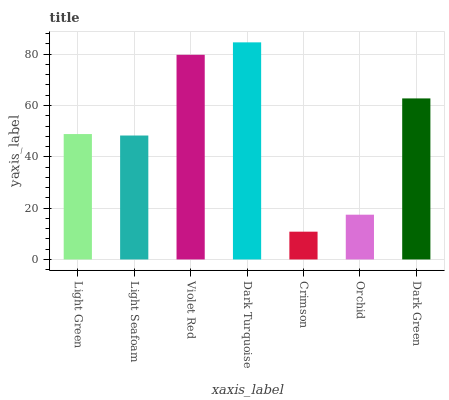Is Crimson the minimum?
Answer yes or no. Yes. Is Dark Turquoise the maximum?
Answer yes or no. Yes. Is Light Seafoam the minimum?
Answer yes or no. No. Is Light Seafoam the maximum?
Answer yes or no. No. Is Light Green greater than Light Seafoam?
Answer yes or no. Yes. Is Light Seafoam less than Light Green?
Answer yes or no. Yes. Is Light Seafoam greater than Light Green?
Answer yes or no. No. Is Light Green less than Light Seafoam?
Answer yes or no. No. Is Light Green the high median?
Answer yes or no. Yes. Is Light Green the low median?
Answer yes or no. Yes. Is Dark Turquoise the high median?
Answer yes or no. No. Is Crimson the low median?
Answer yes or no. No. 